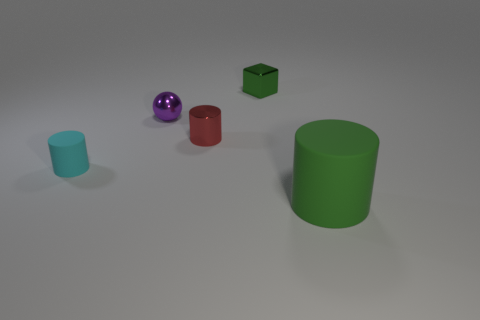Add 3 large red spheres. How many objects exist? 8 Subtract all cubes. How many objects are left? 4 Add 4 tiny spheres. How many tiny spheres are left? 5 Add 1 purple spheres. How many purple spheres exist? 2 Subtract 1 green cubes. How many objects are left? 4 Subtract all cyan cylinders. Subtract all gray blocks. How many objects are left? 4 